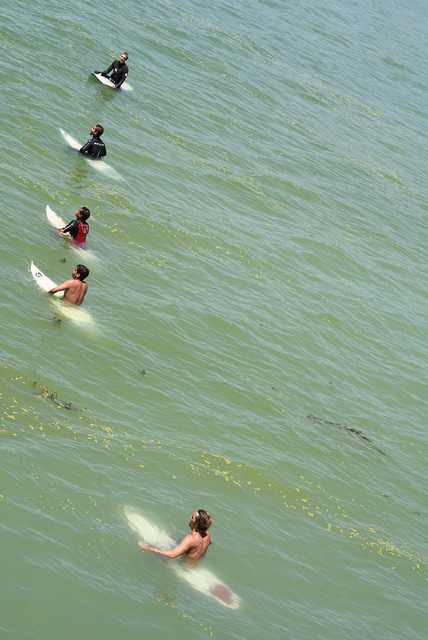Are all the people in this scene facing in the same direction?
Answer the question using a single word or phrase. Yes How many surfboards are on the water? 5 Do all the surfers have their upper torso covered? No 